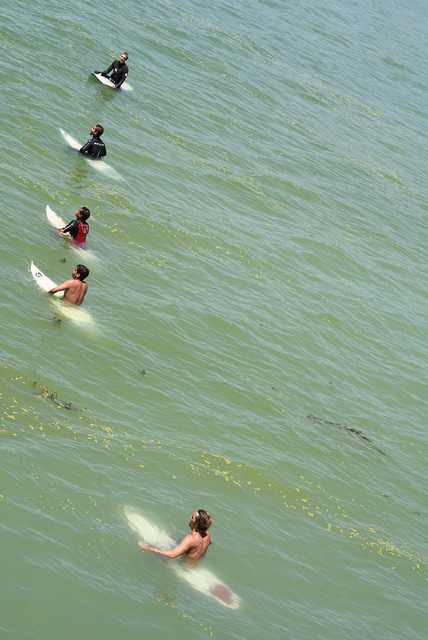Are all the people in this scene facing in the same direction?
Answer the question using a single word or phrase. Yes How many surfboards are on the water? 5 Do all the surfers have their upper torso covered? No 